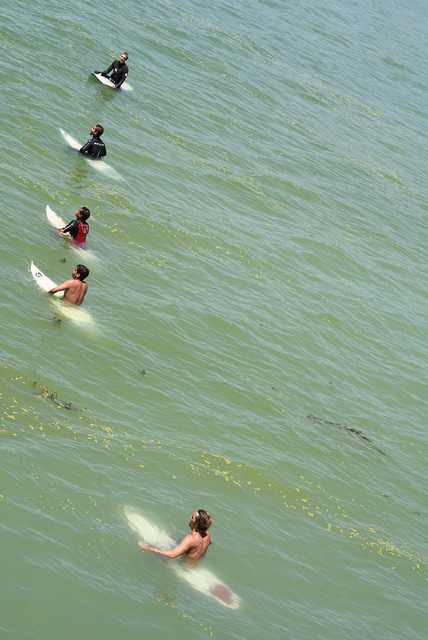Are all the people in this scene facing in the same direction?
Answer the question using a single word or phrase. Yes How many surfboards are on the water? 5 Do all the surfers have their upper torso covered? No 